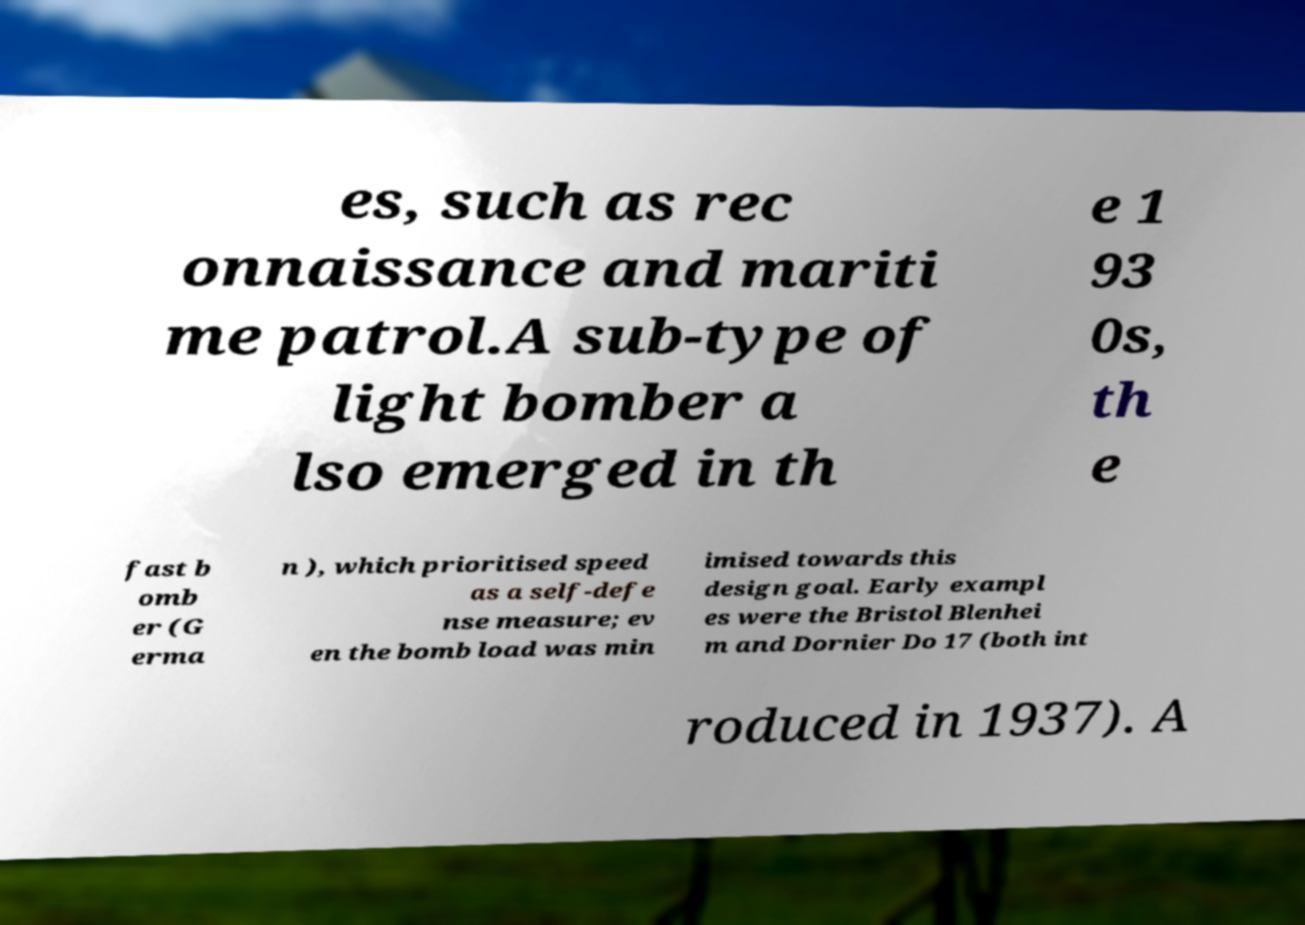Can you accurately transcribe the text from the provided image for me? es, such as rec onnaissance and mariti me patrol.A sub-type of light bomber a lso emerged in th e 1 93 0s, th e fast b omb er (G erma n ), which prioritised speed as a self-defe nse measure; ev en the bomb load was min imised towards this design goal. Early exampl es were the Bristol Blenhei m and Dornier Do 17 (both int roduced in 1937). A 